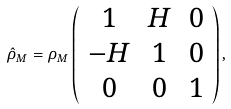Convert formula to latex. <formula><loc_0><loc_0><loc_500><loc_500>\hat { \rho } _ { M } = \rho _ { M } \left ( \begin{array} { c c c } 1 & H & 0 \\ - H & 1 & 0 \\ 0 & 0 & 1 \end{array} \right ) ,</formula> 